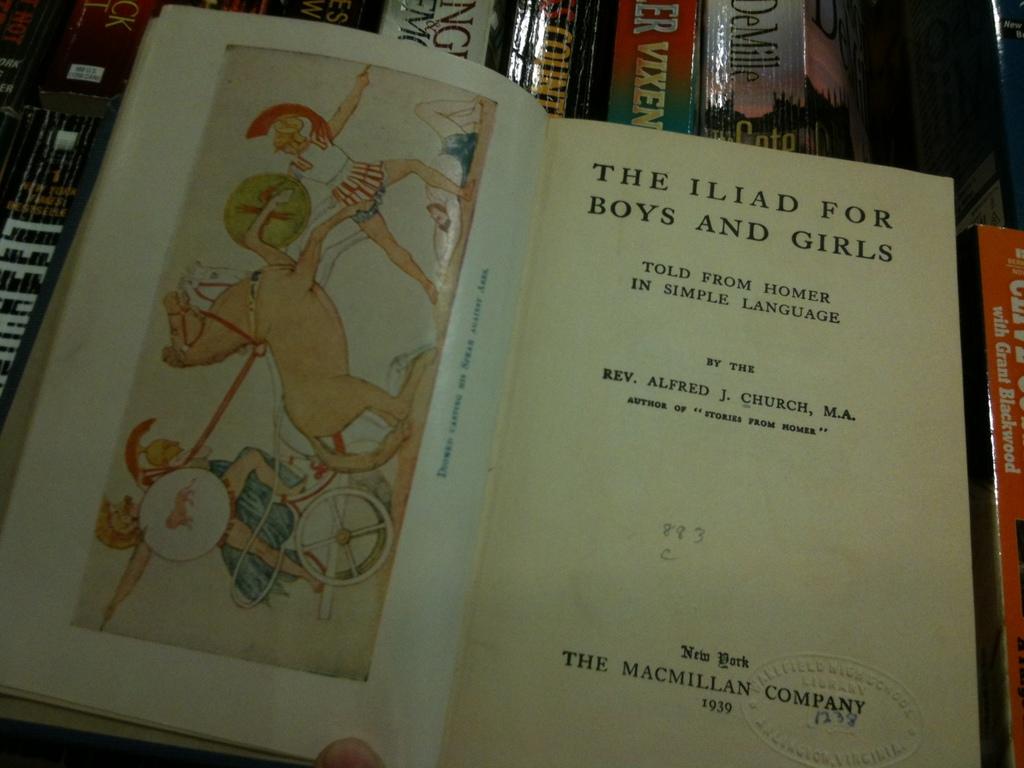The macmillan company did this book in what year?
Offer a terse response. 1939. What is the title of this book?
Provide a short and direct response. The iliad for boys and girls. 